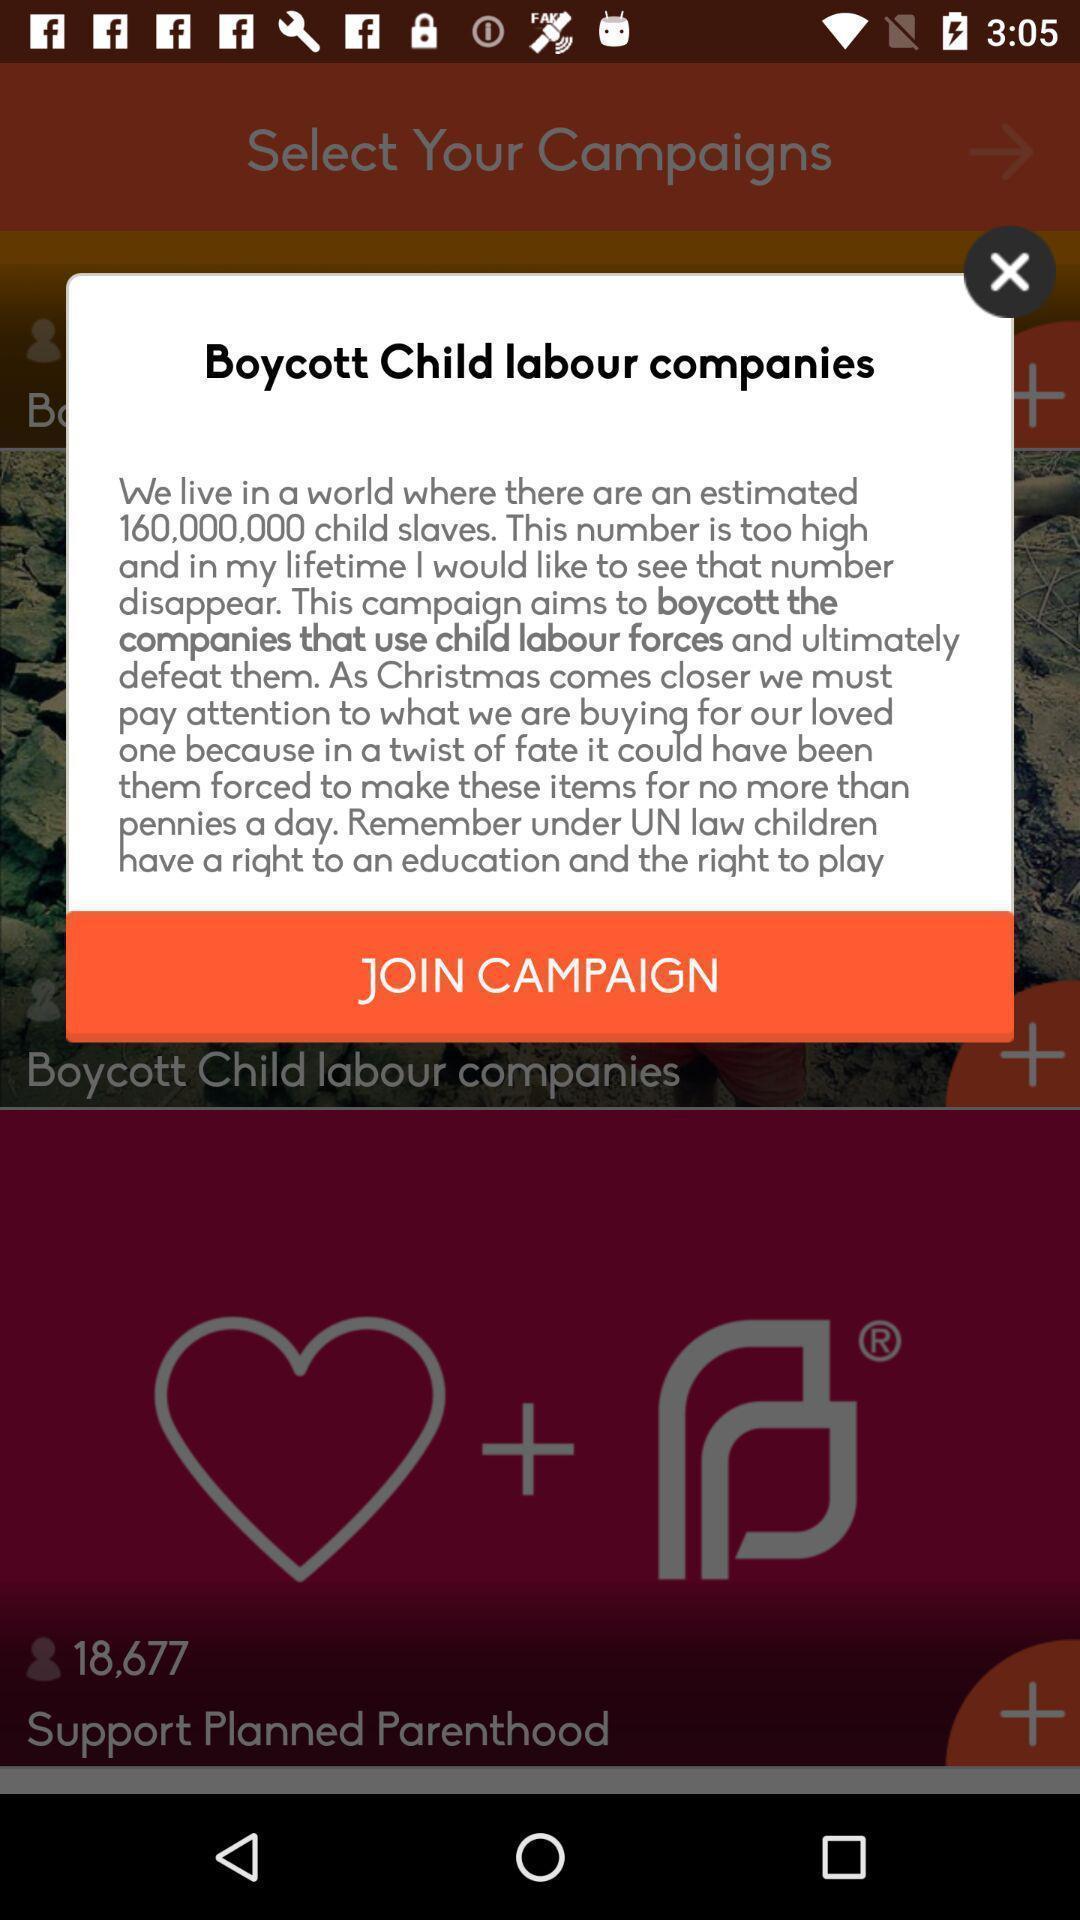Describe the key features of this screenshot. Pop-up showing to join campaign. 